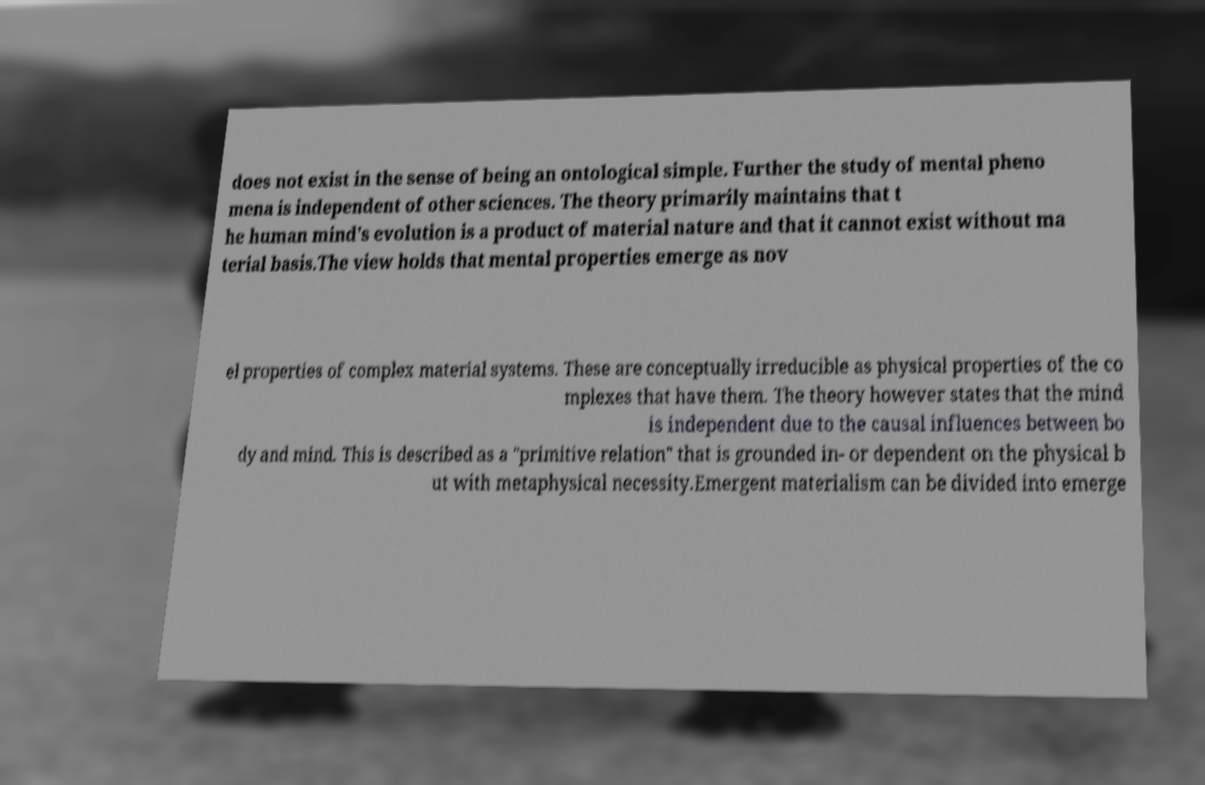Please read and relay the text visible in this image. What does it say? does not exist in the sense of being an ontological simple. Further the study of mental pheno mena is independent of other sciences. The theory primarily maintains that t he human mind's evolution is a product of material nature and that it cannot exist without ma terial basis.The view holds that mental properties emerge as nov el properties of complex material systems. These are conceptually irreducible as physical properties of the co mplexes that have them. The theory however states that the mind is independent due to the causal influences between bo dy and mind. This is described as a "primitive relation" that is grounded in- or dependent on the physical b ut with metaphysical necessity.Emergent materialism can be divided into emerge 